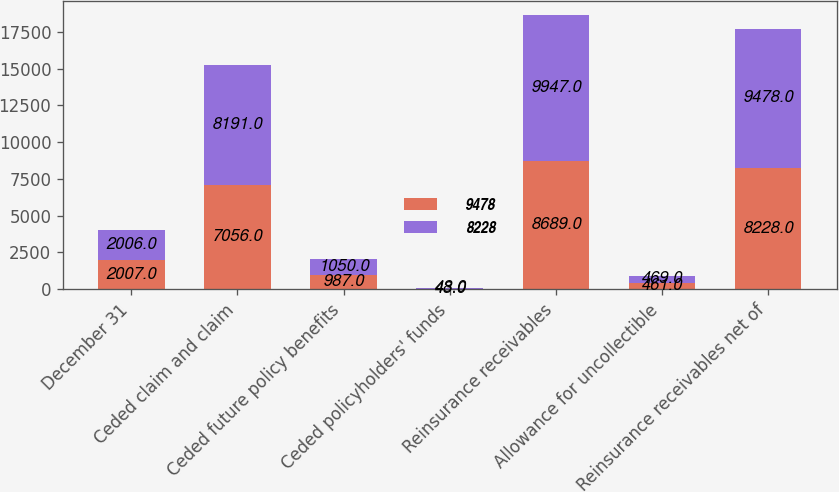Convert chart. <chart><loc_0><loc_0><loc_500><loc_500><stacked_bar_chart><ecel><fcel>December 31<fcel>Ceded claim and claim<fcel>Ceded future policy benefits<fcel>Ceded policyholders' funds<fcel>Reinsurance receivables<fcel>Allowance for uncollectible<fcel>Reinsurance receivables net of<nl><fcel>9478<fcel>2007<fcel>7056<fcel>987<fcel>43<fcel>8689<fcel>461<fcel>8228<nl><fcel>8228<fcel>2006<fcel>8191<fcel>1050<fcel>48<fcel>9947<fcel>469<fcel>9478<nl></chart> 